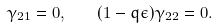<formula> <loc_0><loc_0><loc_500><loc_500>\gamma _ { 2 1 } = 0 , \quad ( 1 - q \epsilon ) \gamma _ { 2 2 } = 0 .</formula> 